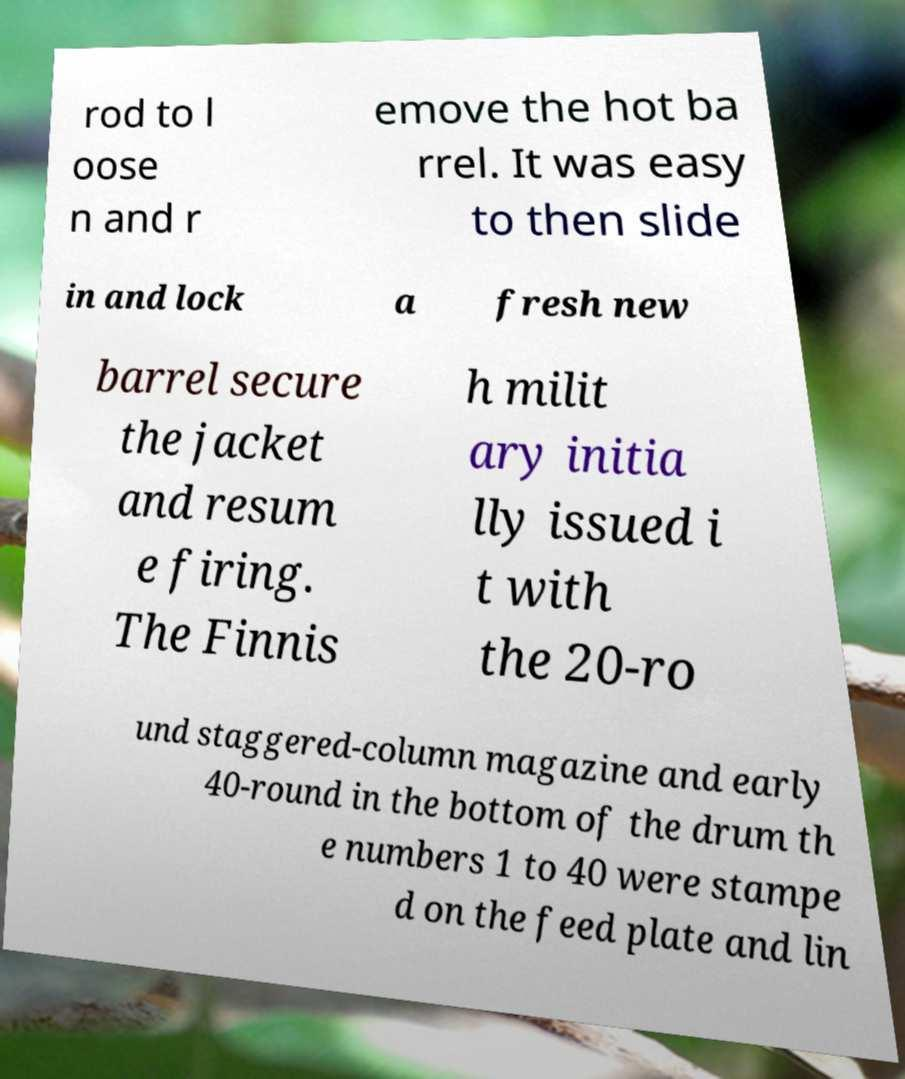Can you accurately transcribe the text from the provided image for me? rod to l oose n and r emove the hot ba rrel. It was easy to then slide in and lock a fresh new barrel secure the jacket and resum e firing. The Finnis h milit ary initia lly issued i t with the 20-ro und staggered-column magazine and early 40-round in the bottom of the drum th e numbers 1 to 40 were stampe d on the feed plate and lin 